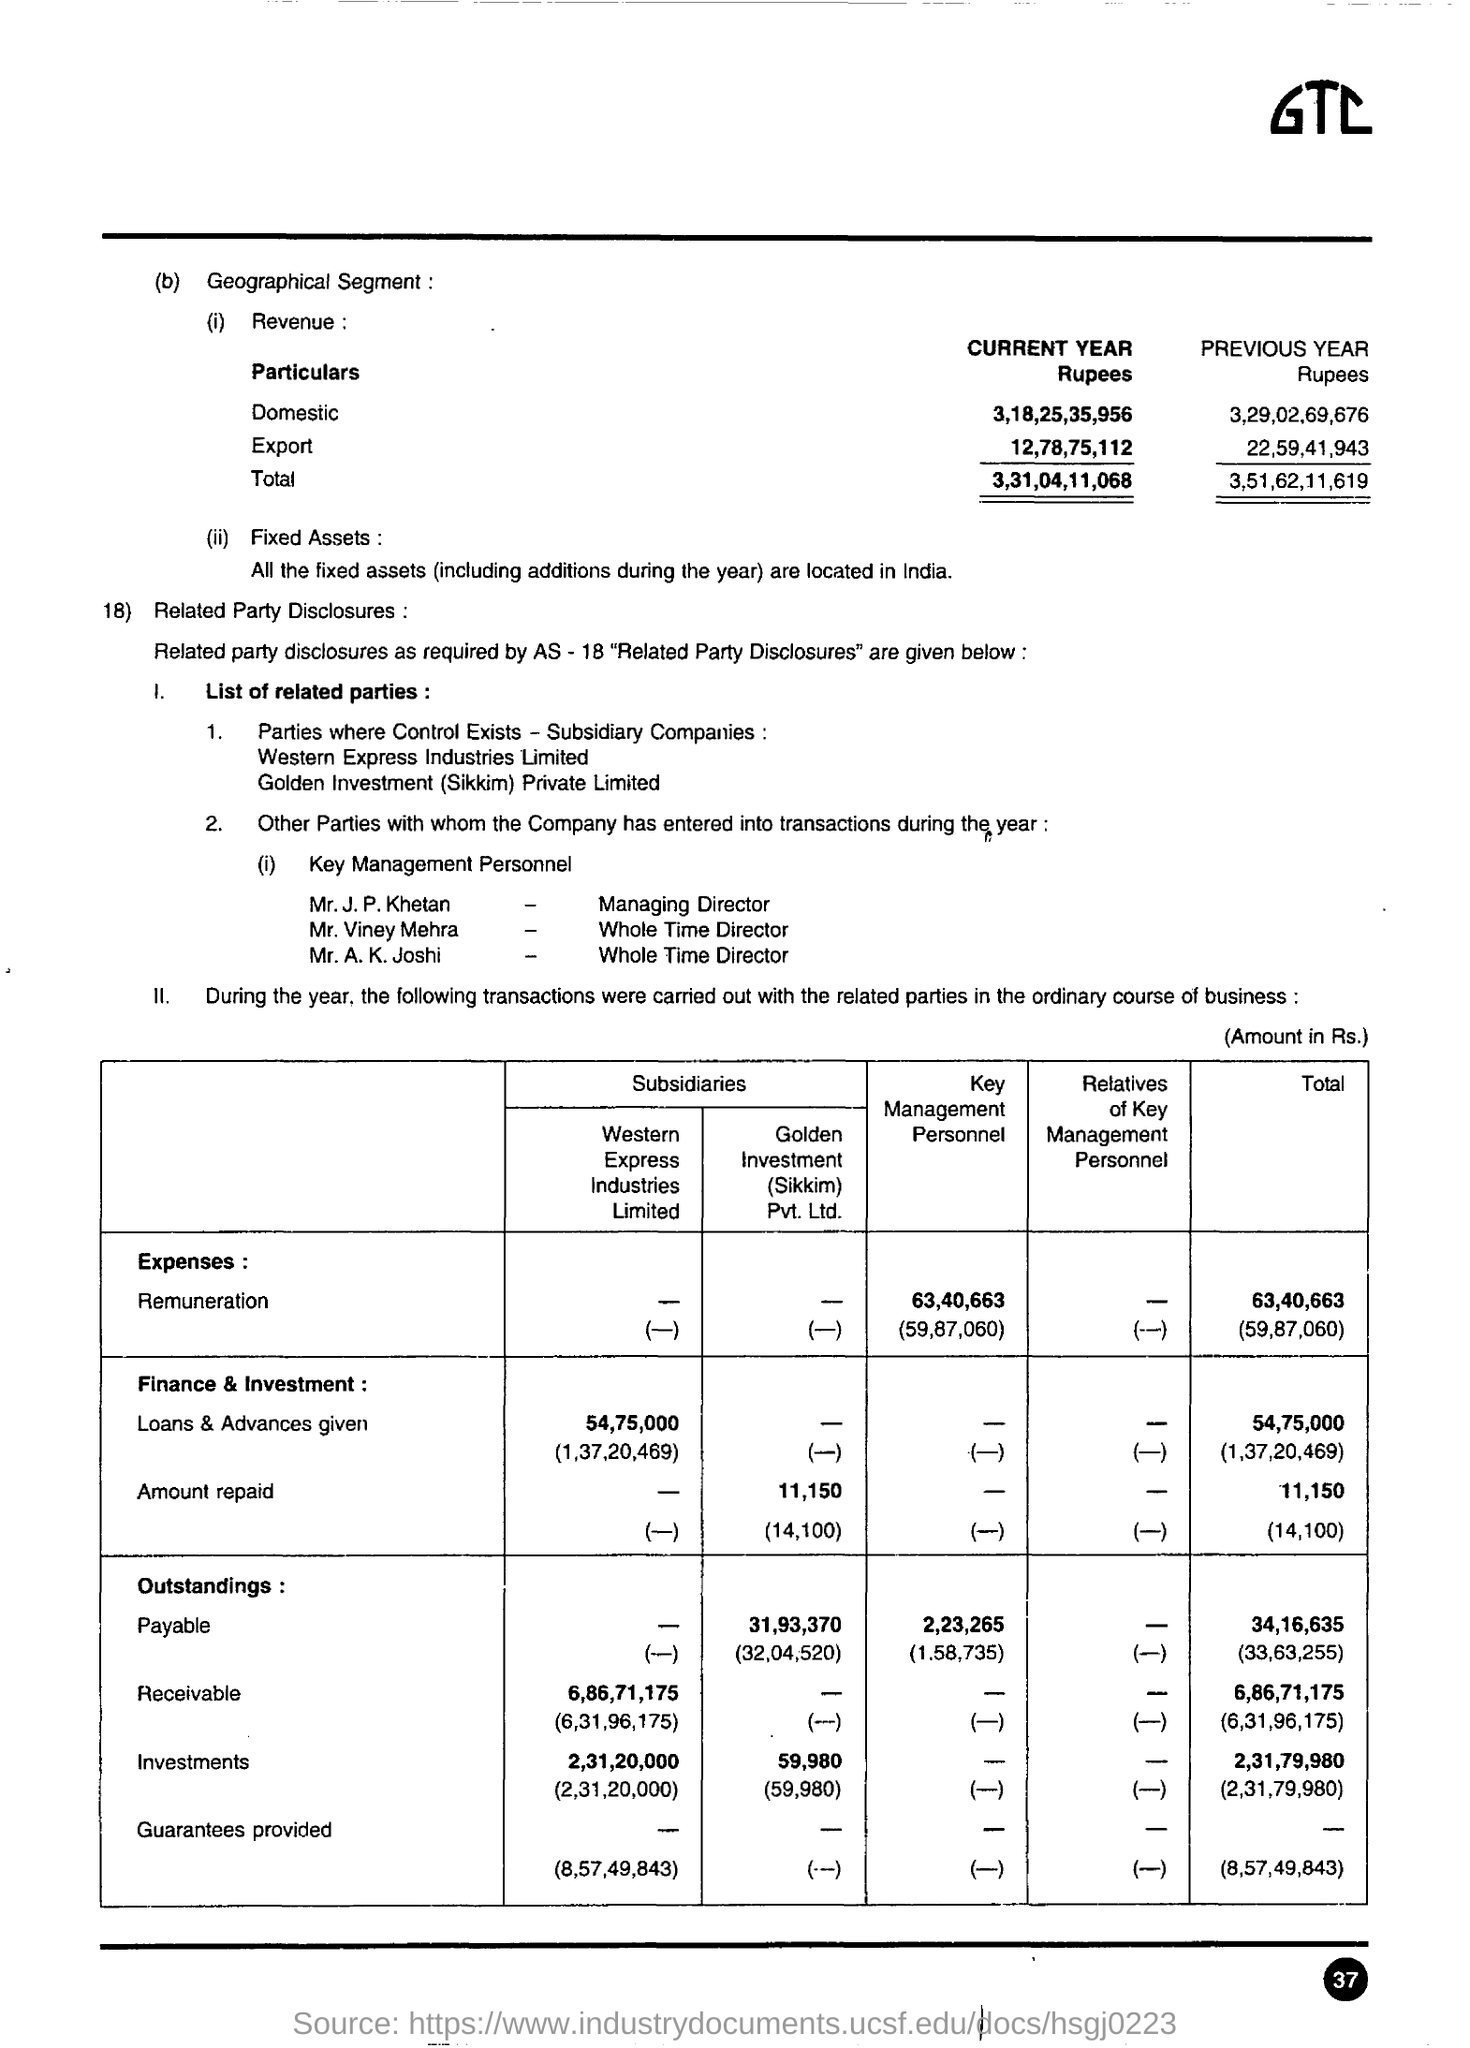What is the total revenue for current year
Offer a terse response. 3,31,04,11,068. What is the total revenue for previous year
Offer a terse response. 3,51,62,11,619. What is the domestic revenue for the current year rupees ?
Provide a short and direct response. 3,18,25,35,956. What is the domestic revenue for the previous year rupees ?
Your answer should be very brief. 3,29,02,69,676. What is the total expenses ?
Provide a succinct answer. 63,40,663. In the finance & investment what is the total amount repaid ?
Your answer should be compact. 11,150. In the finance & investment what is the amount repaid by the golden investment /(sikkim) pvt Ltd .
Give a very brief answer. 11,150. 